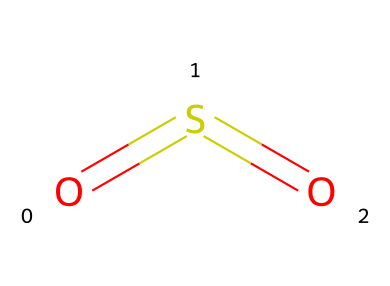How many oxygen atoms are in this compound? The SMILES representation "O=S=O" indicates that there are two oxygen atoms, which are represented by the two 'O' characters in the notation.
Answer: 2 What is the type of chemical bond between sulfur and oxygen in this structure? In the SMILES "O=S=O", the '=' symbol denotes double bonds. Thus, sulfur (S) forms two double bonds with each of the two oxygen atoms (O).
Answer: double bond What is the molecular geometry of sulfur dioxide? Based on the structure indicated in the SMILES "O=S=O", sulfur dioxide (SO2) features a bent or V-shaped molecular geometry due to the two double bonds and the lone pairs on the sulfur atom affecting the bond angles.
Answer: bent What is the total number of atoms in this molecule? The SMILES "O=S=O" contains three atoms total: one sulfur (S) and two oxygen (O) atoms. Adding them up gives a total count of three.
Answer: 3 Is sulfur dioxide a sulfur compound? Yes, because sulfur dioxide (SO2) has sulfur (S) as a central atom bonded to oxygen (O) atoms, it falls under the category of sulfur compounds.
Answer: yes What are the potential environmental effects of sulfur dioxide? Sulfur dioxide (SO2) can lead to air pollution, contributing to the formation of acid rain and respiratory issues in living organisms. Therefore, the effects are typically harmful to both the environment and human health.
Answer: harmful 